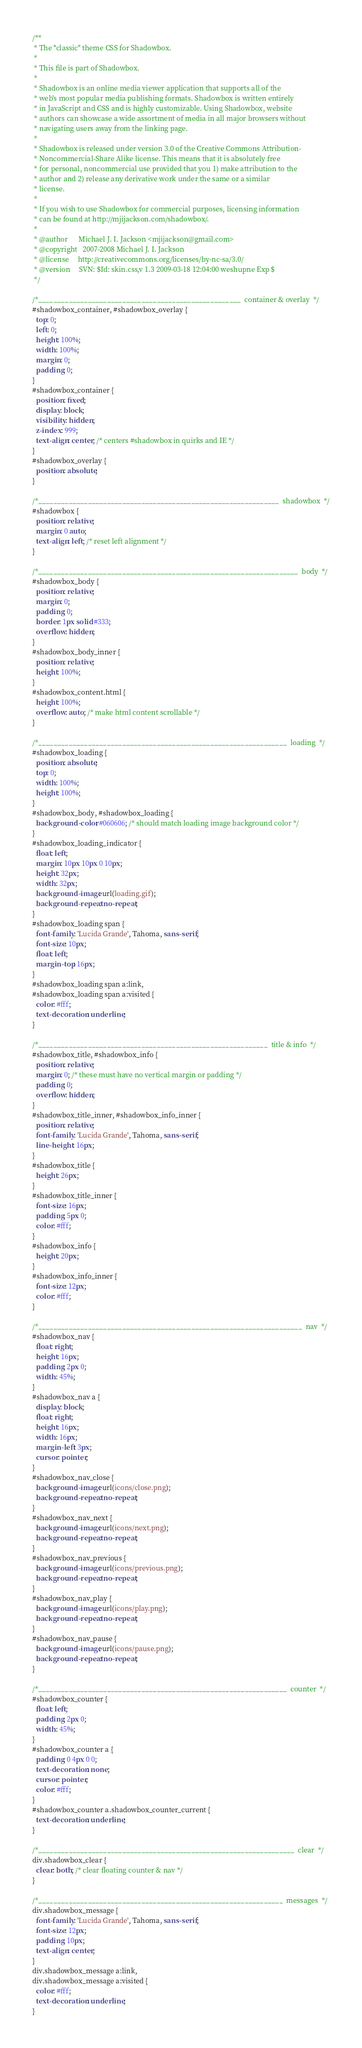Convert code to text. <code><loc_0><loc_0><loc_500><loc_500><_CSS_>/**
 * The "classic" theme CSS for Shadowbox.
 *
 * This file is part of Shadowbox.
 *
 * Shadowbox is an online media viewer application that supports all of the
 * web's most popular media publishing formats. Shadowbox is written entirely
 * in JavaScript and CSS and is highly customizable. Using Shadowbox, website
 * authors can showcase a wide assortment of media in all major browsers without
 * navigating users away from the linking page.
 *
 * Shadowbox is released under version 3.0 of the Creative Commons Attribution-
 * Noncommercial-Share Alike license. This means that it is absolutely free
 * for personal, noncommercial use provided that you 1) make attribution to the
 * author and 2) release any derivative work under the same or a similar
 * license.
 *
 * If you wish to use Shadowbox for commercial purposes, licensing information
 * can be found at http://mjijackson.com/shadowbox/.
 *
 * @author      Michael J. I. Jackson <mjijackson@gmail.com>
 * @copyright   2007-2008 Michael J. I. Jackson
 * @license     http://creativecommons.org/licenses/by-nc-sa/3.0/
 * @version     SVN: $Id: skin.css,v 1.3 2009-03-18 12:04:00 weshupne Exp $
 */

/*_____________________________________________________  container & overlay  */
#shadowbox_container, #shadowbox_overlay {
  top: 0;
  left: 0;
  height: 100%;
  width: 100%;
  margin: 0;
  padding: 0;
}
#shadowbox_container {
  position: fixed;
  display: block;
  visibility: hidden;
  z-index: 999;
  text-align: center; /* centers #shadowbox in quirks and IE */
}
#shadowbox_overlay {
  position: absolute;
}

/*_______________________________________________________________  shadowbox  */
#shadowbox {
  position: relative;
  margin: 0 auto;
  text-align: left; /* reset left alignment */
}

/*____________________________________________________________________  body  */
#shadowbox_body {
  position: relative;
  margin: 0;
  padding: 0;
  border: 1px solid #333;
  overflow: hidden;
}
#shadowbox_body_inner {
  position: relative;
  height: 100%;
}
#shadowbox_content.html {
  height: 100%;
  overflow: auto; /* make html content scrollable */
}

/*_________________________________________________________________  loading  */
#shadowbox_loading {
  position: absolute;
  top: 0;
  width: 100%;
  height: 100%;
}
#shadowbox_body, #shadowbox_loading {
  background-color: #060606; /* should match loading image background color */
}
#shadowbox_loading_indicator {
  float: left;
  margin: 10px 10px 0 10px;
  height: 32px;
  width: 32px;
  background-image: url(loading.gif);
  background-repeat: no-repeat;
}
#shadowbox_loading span {
  font-family: 'Lucida Grande', Tahoma, sans-serif;
  font-size: 10px;
  float: left;
  margin-top: 16px;
}
#shadowbox_loading span a:link,
#shadowbox_loading span a:visited {
  color: #fff;
  text-decoration: underline;
}

/*____________________________________________________________  title & info  */
#shadowbox_title, #shadowbox_info {
  position: relative;
  margin: 0; /* these must have no vertical margin or padding */
  padding: 0;
  overflow: hidden;
}
#shadowbox_title_inner, #shadowbox_info_inner {
  position: relative;
  font-family: 'Lucida Grande', Tahoma, sans-serif;
  line-height: 16px;
}
#shadowbox_title {
  height: 26px;
}
#shadowbox_title_inner {
  font-size: 16px;
  padding: 5px 0;
  color: #fff;
}
#shadowbox_info {
  height: 20px;
}
#shadowbox_info_inner {
  font-size: 12px;
  color: #fff;
}

/*_____________________________________________________________________  nav  */
#shadowbox_nav {
  float: right;
  height: 16px;
  padding: 2px 0;
  width: 45%;
}
#shadowbox_nav a {
  display: block;
  float: right;
  height: 16px;
  width: 16px;
  margin-left: 3px;
  cursor: pointer;
}
#shadowbox_nav_close {
  background-image: url(icons/close.png);
  background-repeat: no-repeat;
}
#shadowbox_nav_next {
  background-image: url(icons/next.png);
  background-repeat: no-repeat;
}
#shadowbox_nav_previous {
  background-image: url(icons/previous.png);
  background-repeat: no-repeat;
}
#shadowbox_nav_play {
  background-image: url(icons/play.png);
  background-repeat: no-repeat;
}
#shadowbox_nav_pause {
  background-image: url(icons/pause.png);
  background-repeat: no-repeat;
}

/*_________________________________________________________________  counter  */
#shadowbox_counter {
  float: left;
  padding: 2px 0;
  width: 45%;
}
#shadowbox_counter a {
  padding: 0 4px 0 0;
  text-decoration: none;
  cursor: pointer;
  color: #fff;
}
#shadowbox_counter a.shadowbox_counter_current {
  text-decoration: underline;
}

/*___________________________________________________________________  clear  */
div.shadowbox_clear {
  clear: both; /* clear floating counter & nav */
}

/*________________________________________________________________  messages  */
div.shadowbox_message {
  font-family: 'Lucida Grande', Tahoma, sans-serif;
  font-size: 12px;
  padding: 10px;
  text-align: center;
}
div.shadowbox_message a:link,
div.shadowbox_message a:visited {
  color: #fff;
  text-decoration: underline;
}
</code> 